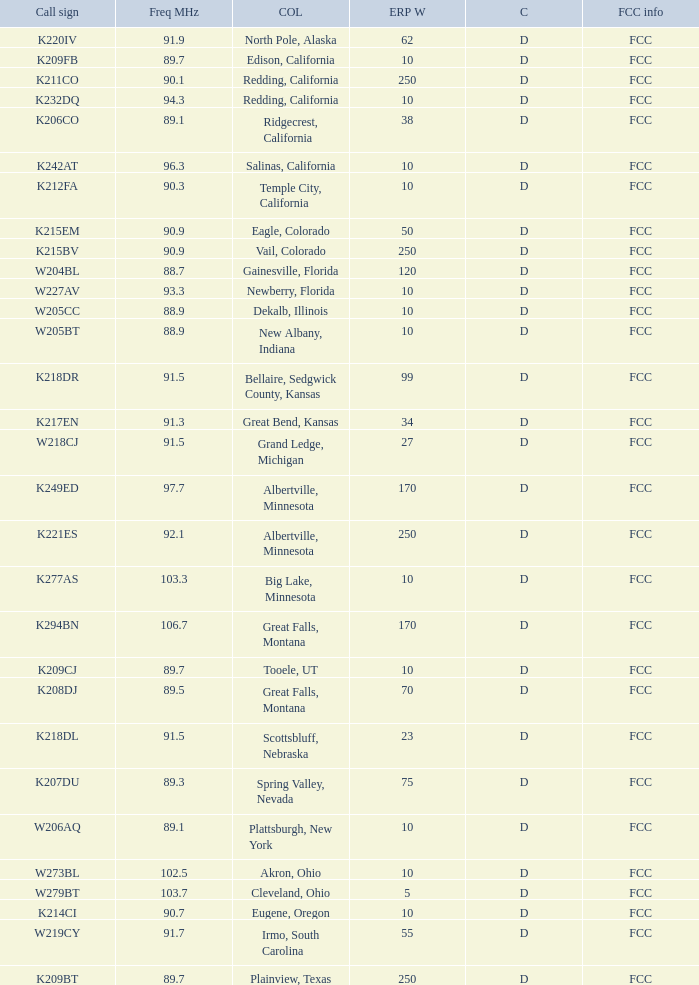What is the call sign of the translator with an ERP W greater than 38 and a city license from Great Falls, Montana? K294BN, K208DJ. Could you help me parse every detail presented in this table? {'header': ['Call sign', 'Freq MHz', 'COL', 'ERP W', 'C', 'FCC info'], 'rows': [['K220IV', '91.9', 'North Pole, Alaska', '62', 'D', 'FCC'], ['K209FB', '89.7', 'Edison, California', '10', 'D', 'FCC'], ['K211CO', '90.1', 'Redding, California', '250', 'D', 'FCC'], ['K232DQ', '94.3', 'Redding, California', '10', 'D', 'FCC'], ['K206CO', '89.1', 'Ridgecrest, California', '38', 'D', 'FCC'], ['K242AT', '96.3', 'Salinas, California', '10', 'D', 'FCC'], ['K212FA', '90.3', 'Temple City, California', '10', 'D', 'FCC'], ['K215EM', '90.9', 'Eagle, Colorado', '50', 'D', 'FCC'], ['K215BV', '90.9', 'Vail, Colorado', '250', 'D', 'FCC'], ['W204BL', '88.7', 'Gainesville, Florida', '120', 'D', 'FCC'], ['W227AV', '93.3', 'Newberry, Florida', '10', 'D', 'FCC'], ['W205CC', '88.9', 'Dekalb, Illinois', '10', 'D', 'FCC'], ['W205BT', '88.9', 'New Albany, Indiana', '10', 'D', 'FCC'], ['K218DR', '91.5', 'Bellaire, Sedgwick County, Kansas', '99', 'D', 'FCC'], ['K217EN', '91.3', 'Great Bend, Kansas', '34', 'D', 'FCC'], ['W218CJ', '91.5', 'Grand Ledge, Michigan', '27', 'D', 'FCC'], ['K249ED', '97.7', 'Albertville, Minnesota', '170', 'D', 'FCC'], ['K221ES', '92.1', 'Albertville, Minnesota', '250', 'D', 'FCC'], ['K277AS', '103.3', 'Big Lake, Minnesota', '10', 'D', 'FCC'], ['K294BN', '106.7', 'Great Falls, Montana', '170', 'D', 'FCC'], ['K209CJ', '89.7', 'Tooele, UT', '10', 'D', 'FCC'], ['K208DJ', '89.5', 'Great Falls, Montana', '70', 'D', 'FCC'], ['K218DL', '91.5', 'Scottsbluff, Nebraska', '23', 'D', 'FCC'], ['K207DU', '89.3', 'Spring Valley, Nevada', '75', 'D', 'FCC'], ['W206AQ', '89.1', 'Plattsburgh, New York', '10', 'D', 'FCC'], ['W273BL', '102.5', 'Akron, Ohio', '10', 'D', 'FCC'], ['W279BT', '103.7', 'Cleveland, Ohio', '5', 'D', 'FCC'], ['K214CI', '90.7', 'Eugene, Oregon', '10', 'D', 'FCC'], ['W219CY', '91.7', 'Irmo, South Carolina', '55', 'D', 'FCC'], ['K209BT', '89.7', 'Plainview, Texas', '250', 'D', 'FCC']]} 